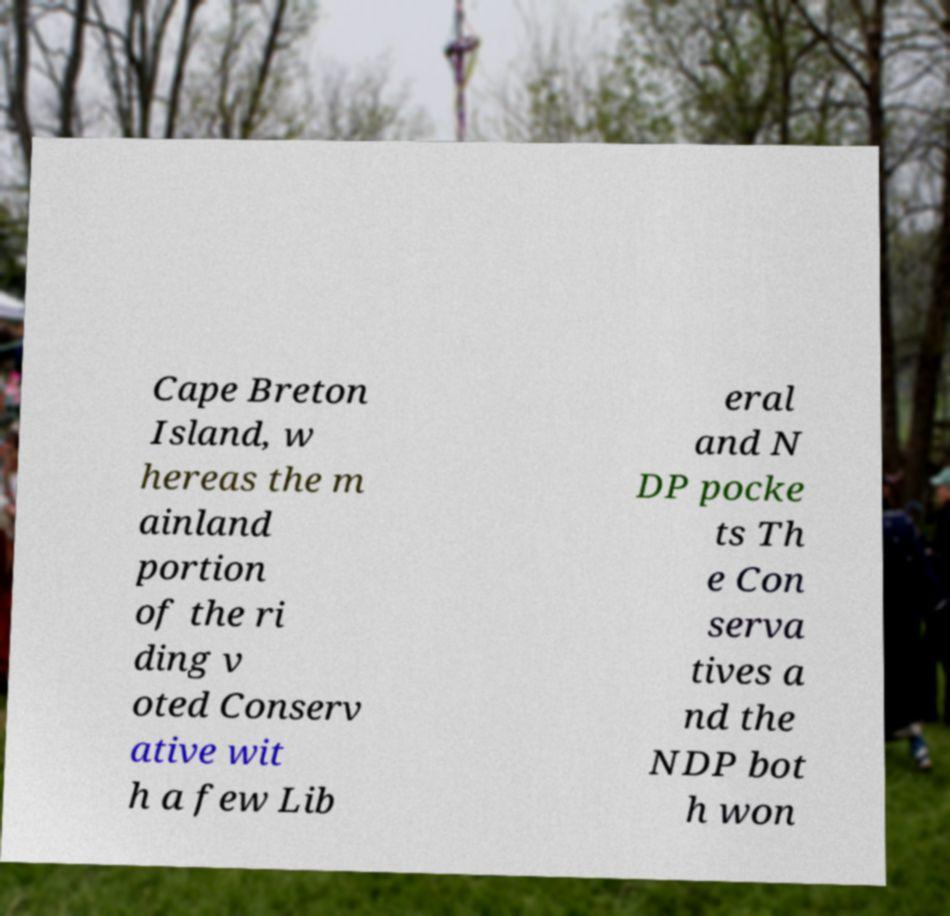I need the written content from this picture converted into text. Can you do that? Cape Breton Island, w hereas the m ainland portion of the ri ding v oted Conserv ative wit h a few Lib eral and N DP pocke ts Th e Con serva tives a nd the NDP bot h won 